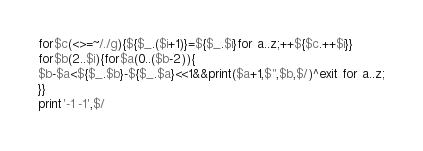Convert code to text. <code><loc_0><loc_0><loc_500><loc_500><_Perl_>for$c(<>=~/./g){${$_.($i+1)}=${$_.$i}for a..z;++${$c.++$i}}
for$b(2..$i){for$a(0..($b-2)){
$b-$a<${$_.$b}-${$_.$a}<<1&&print($a+1,$",$b,$/)^exit for a..z;
}}
print'-1 -1',$/</code> 